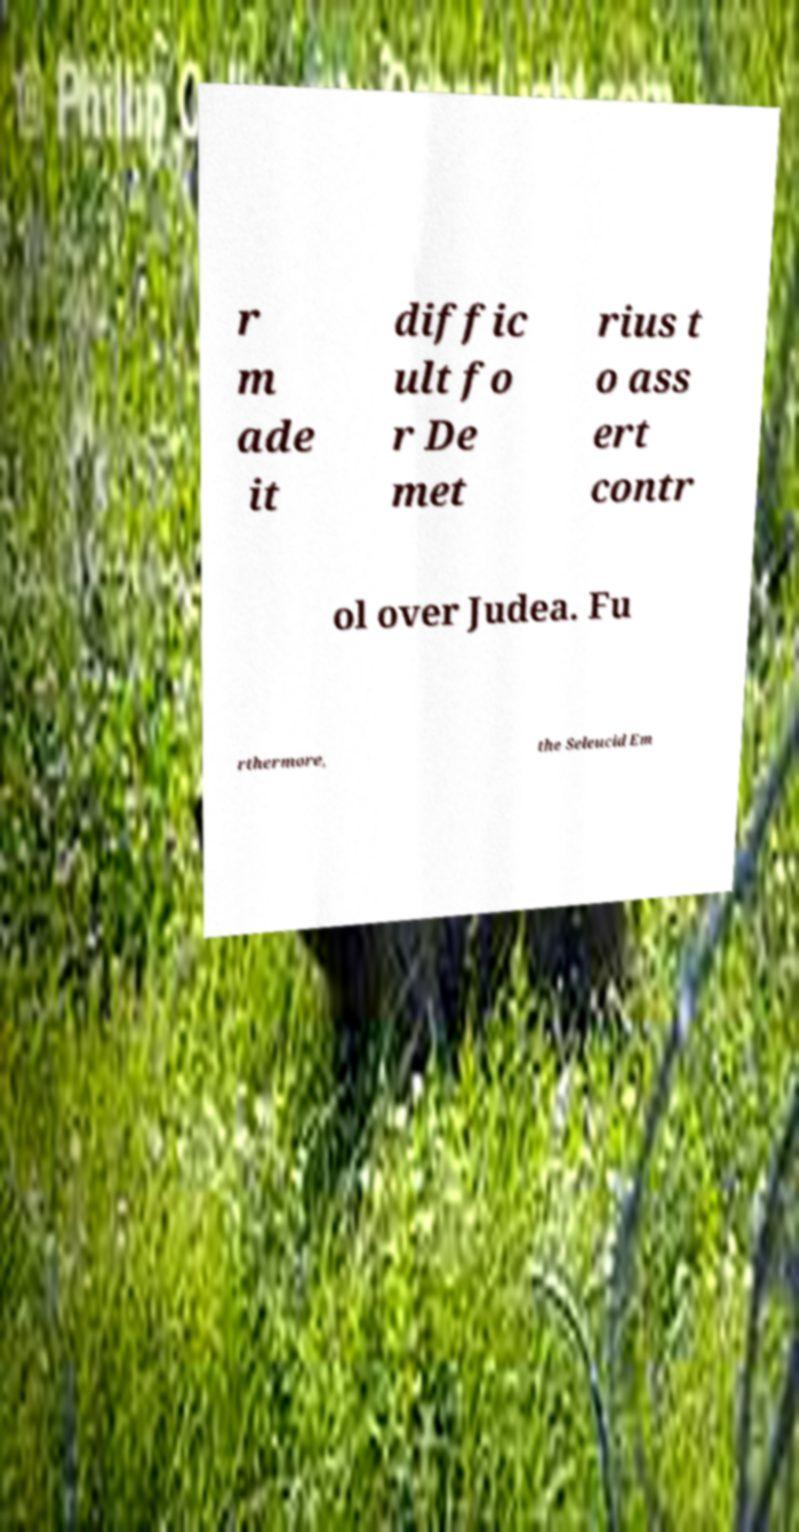I need the written content from this picture converted into text. Can you do that? r m ade it diffic ult fo r De met rius t o ass ert contr ol over Judea. Fu rthermore, the Seleucid Em 